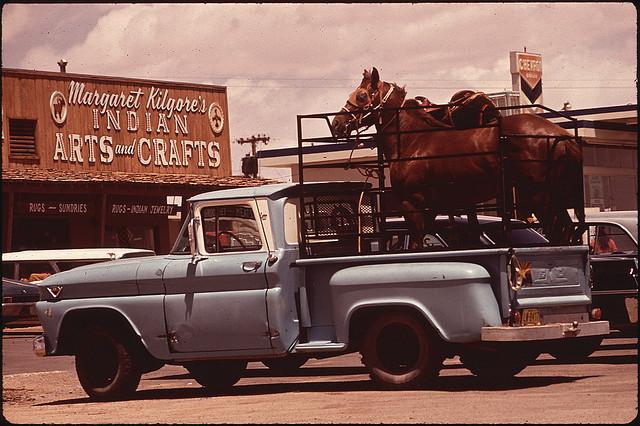What is weird about this picture?
Answer briefly. Horses. What kind of arts and crafts are at the store?
Keep it brief. Indian. What is in the back of the truck?
Answer briefly. Horse. Is the truck loaded?
Be succinct. Yes. 